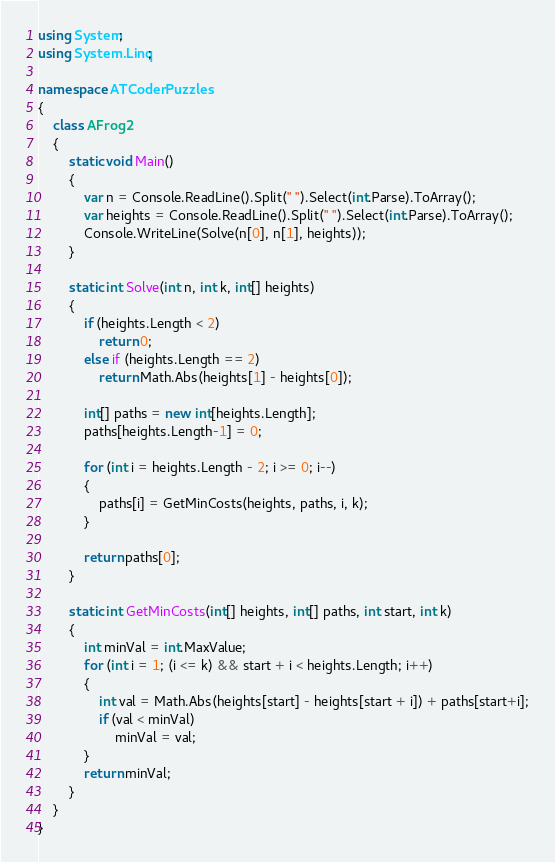Convert code to text. <code><loc_0><loc_0><loc_500><loc_500><_C#_>using System;
using System.Linq;

namespace ATCoderPuzzles
{
    class AFrog2
    {
        static void Main()
        {
            var n = Console.ReadLine().Split(" ").Select(int.Parse).ToArray();
            var heights = Console.ReadLine().Split(" ").Select(int.Parse).ToArray();
            Console.WriteLine(Solve(n[0], n[1], heights));
        }

        static int Solve(int n, int k, int[] heights)
        {
            if (heights.Length < 2)
                return 0;
            else if (heights.Length == 2)
                return Math.Abs(heights[1] - heights[0]);

            int[] paths = new int[heights.Length];
            paths[heights.Length-1] = 0;

            for (int i = heights.Length - 2; i >= 0; i--)
            {
                paths[i] = GetMinCosts(heights, paths, i, k);
            }

            return paths[0];
        }

        static int GetMinCosts(int[] heights, int[] paths, int start, int k)
        {
            int minVal = int.MaxValue;
            for (int i = 1; (i <= k) && start + i < heights.Length; i++)
            {
                int val = Math.Abs(heights[start] - heights[start + i]) + paths[start+i];
                if (val < minVal)
                    minVal = val;
            }
            return minVal;
        }
    }
}
</code> 